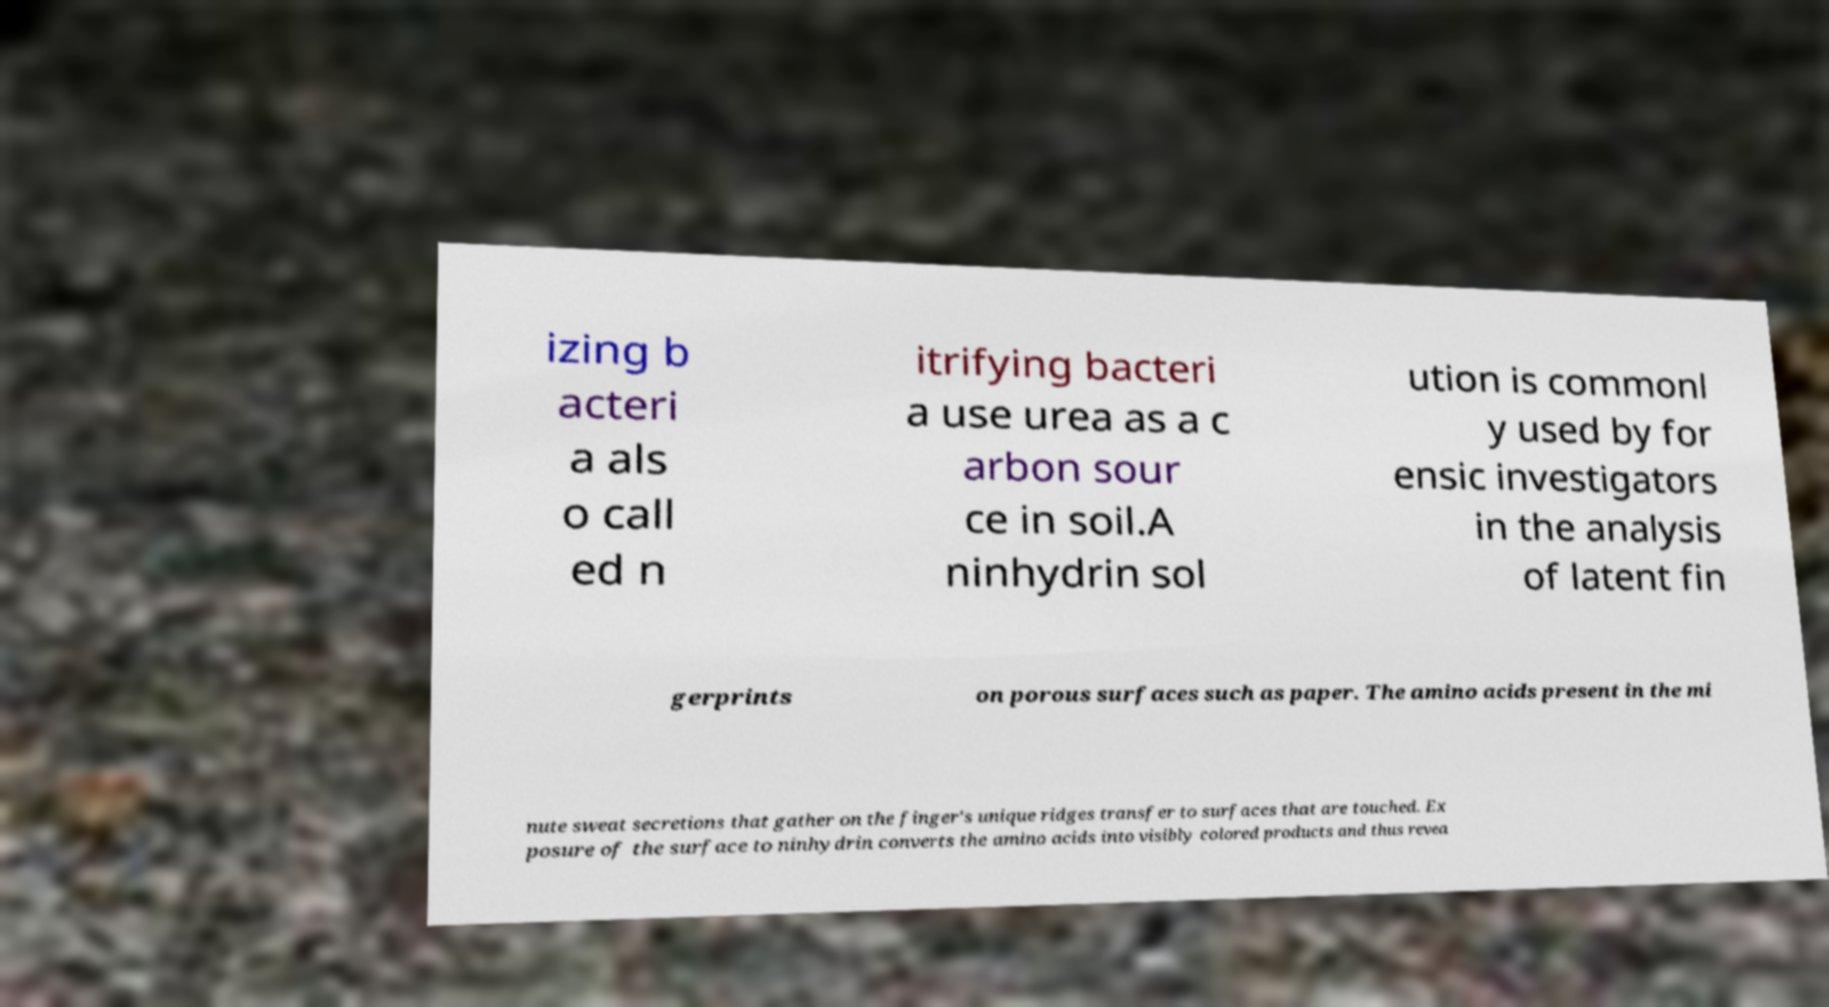Can you accurately transcribe the text from the provided image for me? izing b acteri a als o call ed n itrifying bacteri a use urea as a c arbon sour ce in soil.A ninhydrin sol ution is commonl y used by for ensic investigators in the analysis of latent fin gerprints on porous surfaces such as paper. The amino acids present in the mi nute sweat secretions that gather on the finger's unique ridges transfer to surfaces that are touched. Ex posure of the surface to ninhydrin converts the amino acids into visibly colored products and thus revea 